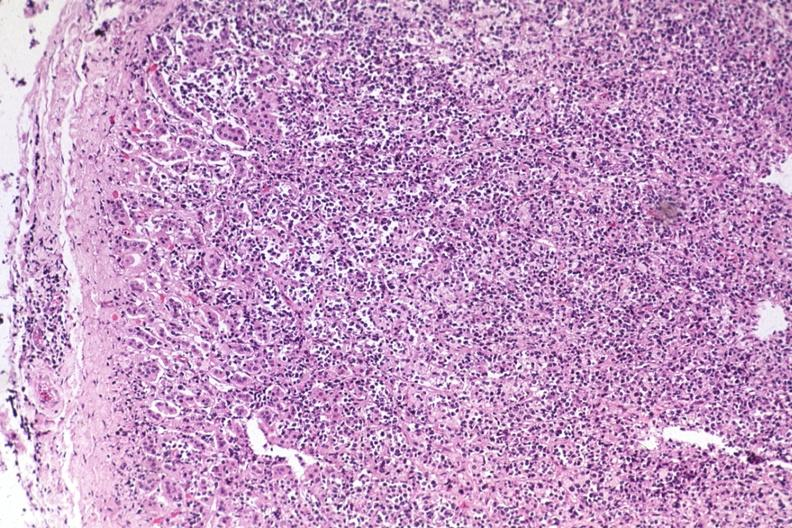does this image show diffuse infiltrate?
Answer the question using a single word or phrase. Yes 